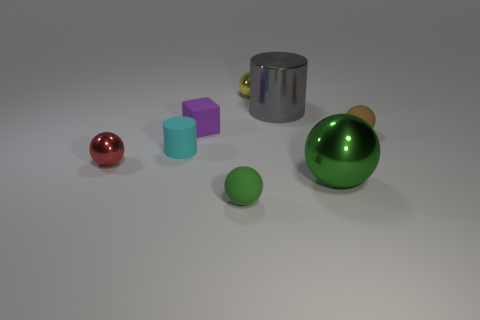There is a thing that is in front of the tiny red metal ball and on the right side of the big gray metal object; how big is it?
Keep it short and to the point. Large. What is the color of the metal cylinder?
Your response must be concise. Gray. How many metal balls are there?
Make the answer very short. 3. How many big metal spheres are the same color as the small rubber cylinder?
Your answer should be very brief. 0. Do the big object behind the tiny red shiny object and the small thing to the right of the yellow metallic object have the same shape?
Keep it short and to the point. No. What color is the matte ball that is behind the small ball that is on the left side of the small rubber sphere in front of the small cyan cylinder?
Provide a short and direct response. Brown. The rubber thing that is in front of the tiny red object is what color?
Provide a succinct answer. Green. The cube that is the same size as the cyan rubber thing is what color?
Give a very brief answer. Purple. Do the red metallic object and the gray shiny cylinder have the same size?
Your response must be concise. No. What number of metal objects are in front of the large gray metallic cylinder?
Keep it short and to the point. 2. 